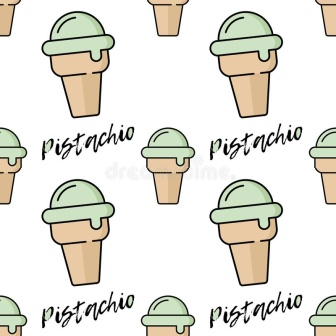If this image were a part of a story, what would the story be about? In a whimsical land where desserts come to life, there exists a magical garden known as the Pistachio Paradise. This garden is tended by playful fairies who cultivate the finest pistachio ice cream cones. The cones grow from special trees, with light brown trunks and green, creamy crowns. Visitors to Pistachio Paradise are greeted with rows and rows of perfectly arranged cones, each one inscribed with the word 'Pistachio' as a reminder of the delightful flavor. The garden is a place of joy and sweetness, where laughter echoes through the air, and the scent of pistachio fills every breath. Children and adults alike come to bask in the happiness that Pistachio Paradise brings, indulging in the creamy treats and partaking in the enchantment of this magical world. 